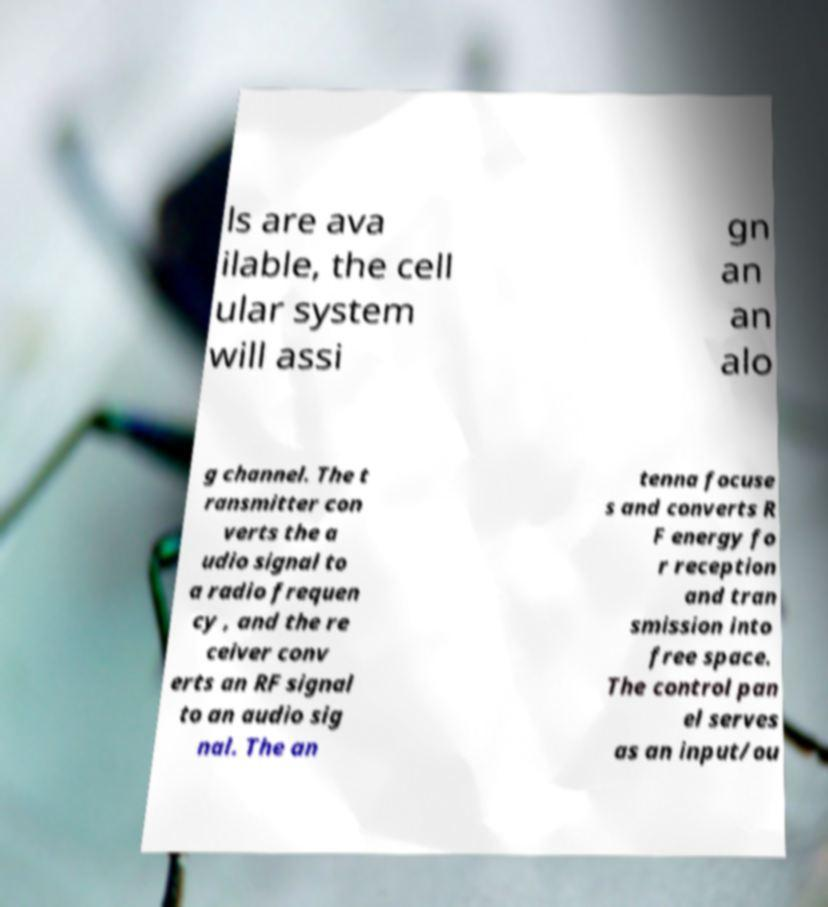Can you accurately transcribe the text from the provided image for me? ls are ava ilable, the cell ular system will assi gn an an alo g channel. The t ransmitter con verts the a udio signal to a radio frequen cy , and the re ceiver conv erts an RF signal to an audio sig nal. The an tenna focuse s and converts R F energy fo r reception and tran smission into free space. The control pan el serves as an input/ou 